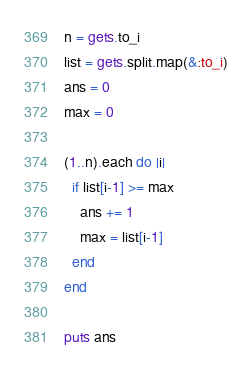<code> <loc_0><loc_0><loc_500><loc_500><_Ruby_>n = gets.to_i
list = gets.split.map(&:to_i)
ans = 0
max = 0

(1..n).each do |i|
  if list[i-1] >= max
    ans += 1
    max = list[i-1]
  end
end

puts ans
</code> 